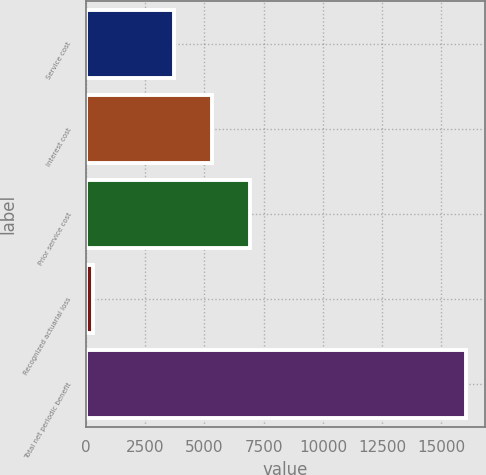<chart> <loc_0><loc_0><loc_500><loc_500><bar_chart><fcel>Service cost<fcel>Interest cost<fcel>Prior service cost<fcel>Recognized actuarial loss<fcel>Total net periodic benefit<nl><fcel>3739<fcel>5311.9<fcel>6927<fcel>286<fcel>16015<nl></chart> 